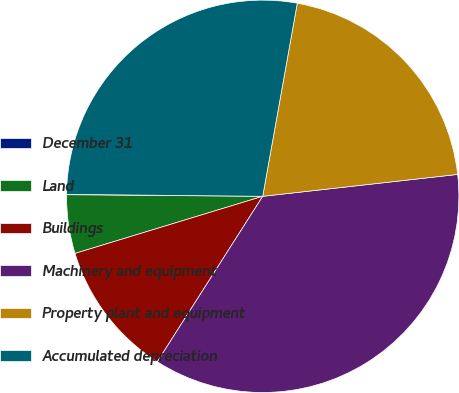Convert chart. <chart><loc_0><loc_0><loc_500><loc_500><pie_chart><fcel>December 31<fcel>Land<fcel>Buildings<fcel>Machinery and equipment<fcel>Property plant and equipment<fcel>Accumulated depreciation<nl><fcel>0.03%<fcel>4.83%<fcel>11.27%<fcel>35.81%<fcel>20.4%<fcel>27.66%<nl></chart> 